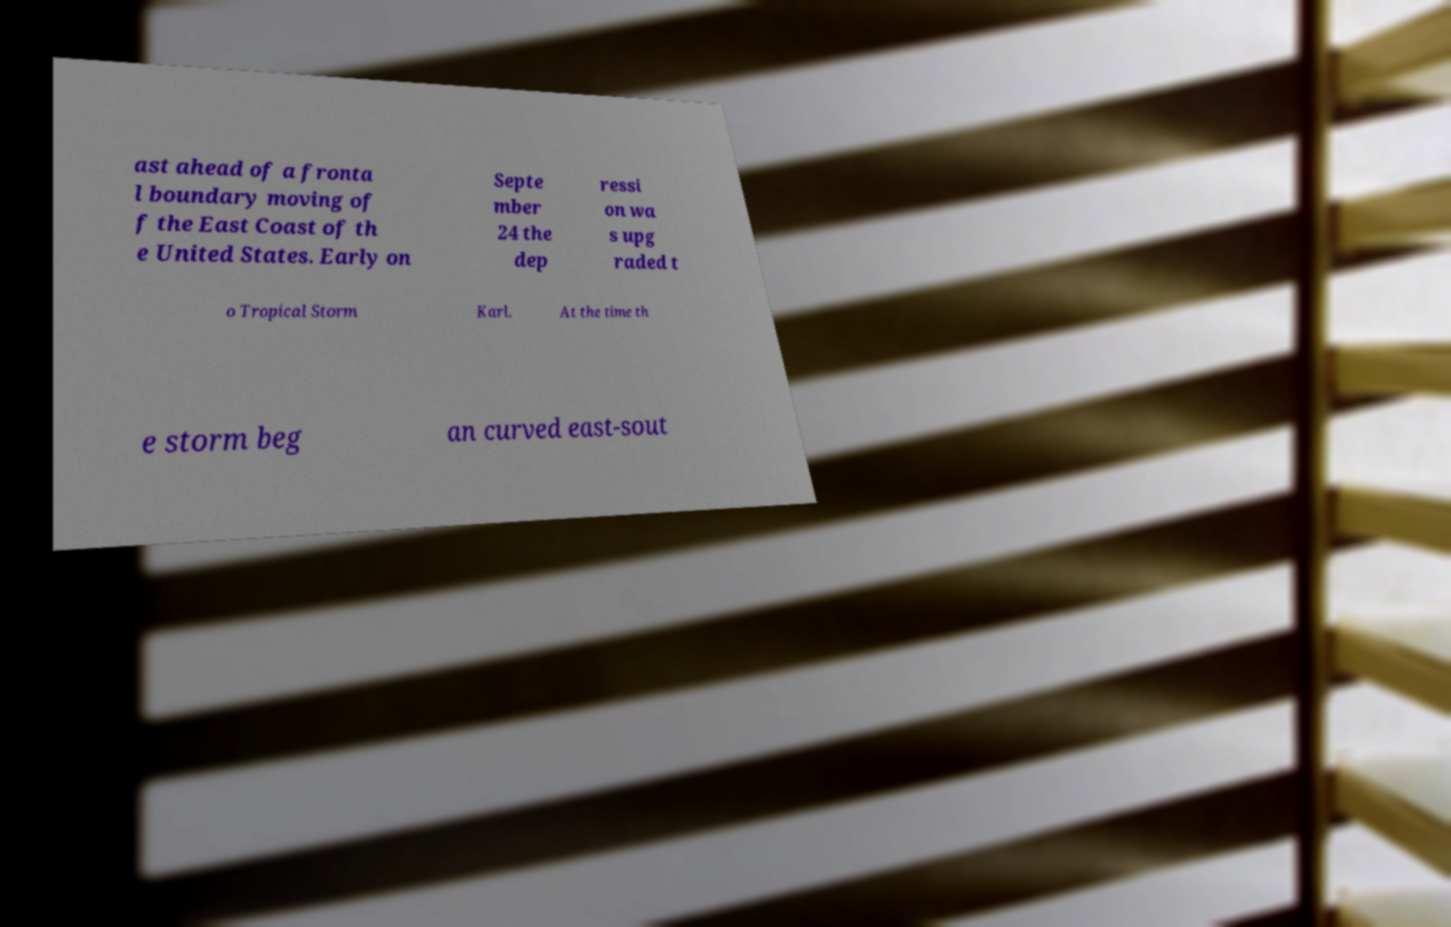I need the written content from this picture converted into text. Can you do that? ast ahead of a fronta l boundary moving of f the East Coast of th e United States. Early on Septe mber 24 the dep ressi on wa s upg raded t o Tropical Storm Karl. At the time th e storm beg an curved east-sout 